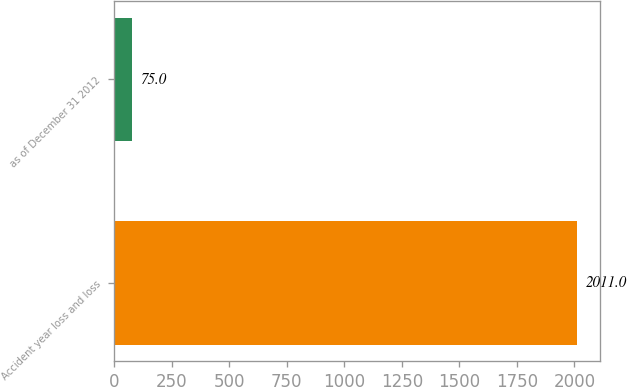Convert chart to OTSL. <chart><loc_0><loc_0><loc_500><loc_500><bar_chart><fcel>Accident year loss and loss<fcel>as of December 31 2012<nl><fcel>2011<fcel>75<nl></chart> 